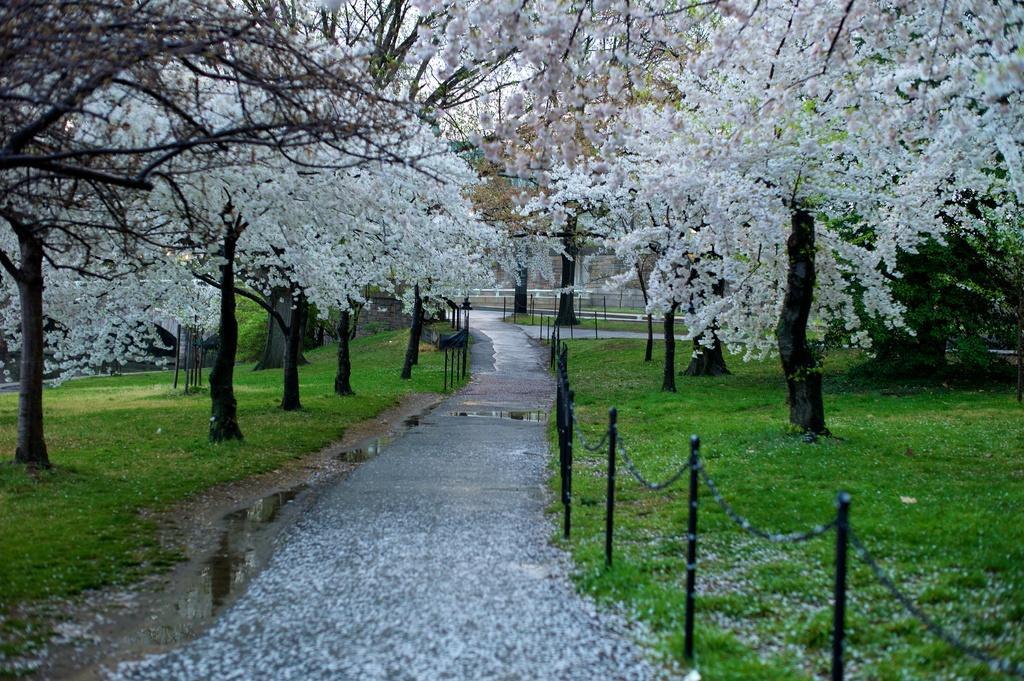Please provide a concise description of this image. This image consists of flowers on the road, water, fence, grass, trees, building and the sky. This image is taken may be in a park. 